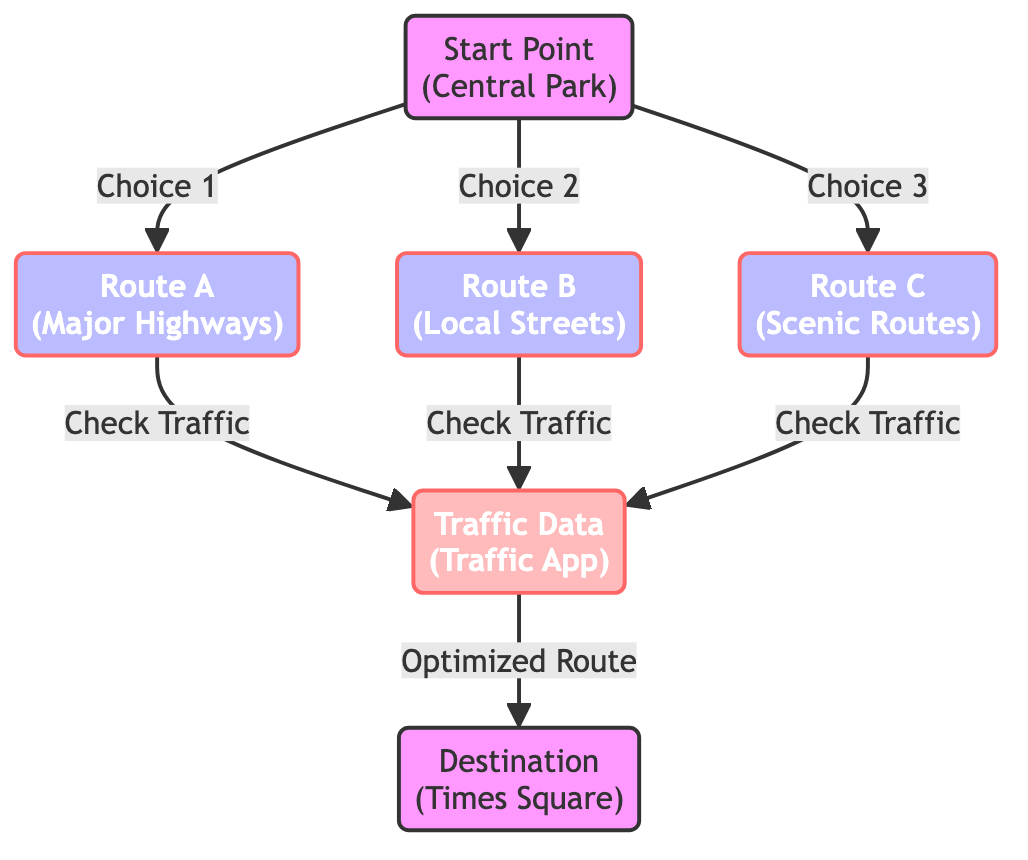What's the starting point in the diagram? The diagram indicates that the starting point is labeled "Central Park." It is the initial node from which choices are made regarding routes.
Answer: Central Park How many routes can be chosen from the start point? The diagram shows three options branching out from the "Start Point": Route A, Route B, and Route C. Each represents a different choice for navigating to the destination.
Answer: 3 What is the destination point in the diagram? The final point in the flowchart is labeled "Times Square." This node represents the target destination for the routes considered.
Answer: Times Square What type of routes are represented in this diagram? The routes depicted in the diagram are labeled as "Major Highways," "Local Streets," and "Scenic Routes." These labels describe the characteristics of each routing choice.
Answer: Major Highways, Local Streets, Scenic Routes Which node comes after checking traffic data? After the traffic data is checked, the flow leads to the node indicating the "Optimized Route." This step occurs before reaching the final destination.
Answer: Optimized Route If a driver chooses Route B, what must they do next? After selecting Route B, the next step is checking traffic data. This action is necessary for determining the effectiveness and time efficiency of the chosen route.
Answer: Check Traffic Which route is likely to provide the fastest travel time based on common perceptions? Generally, "Route A" (Major Highways) is often considered to provide a faster travel time due to less frequent stops compared to the other options.
Answer: Route A What data is used to optimize the chosen route? The diagram states that "Traffic Data" is used to assess and identify the best route for the journey. This data influences the final route decision.
Answer: Traffic Data How many steps are involved in reaching the destination from the start point? There are four steps in the process: starting from Central Park, choosing a route, checking traffic, and then arriving at the destination.
Answer: 4 